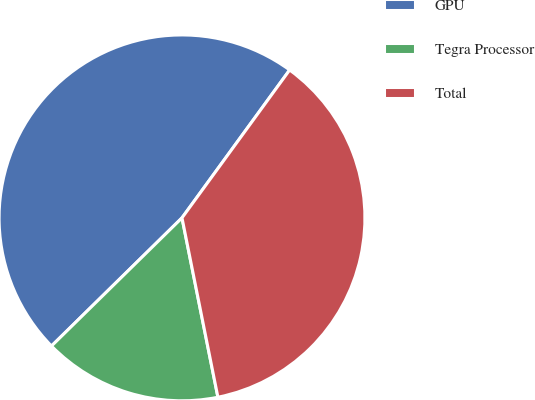Convert chart. <chart><loc_0><loc_0><loc_500><loc_500><pie_chart><fcel>GPU<fcel>Tegra Processor<fcel>Total<nl><fcel>47.37%<fcel>15.79%<fcel>36.84%<nl></chart> 